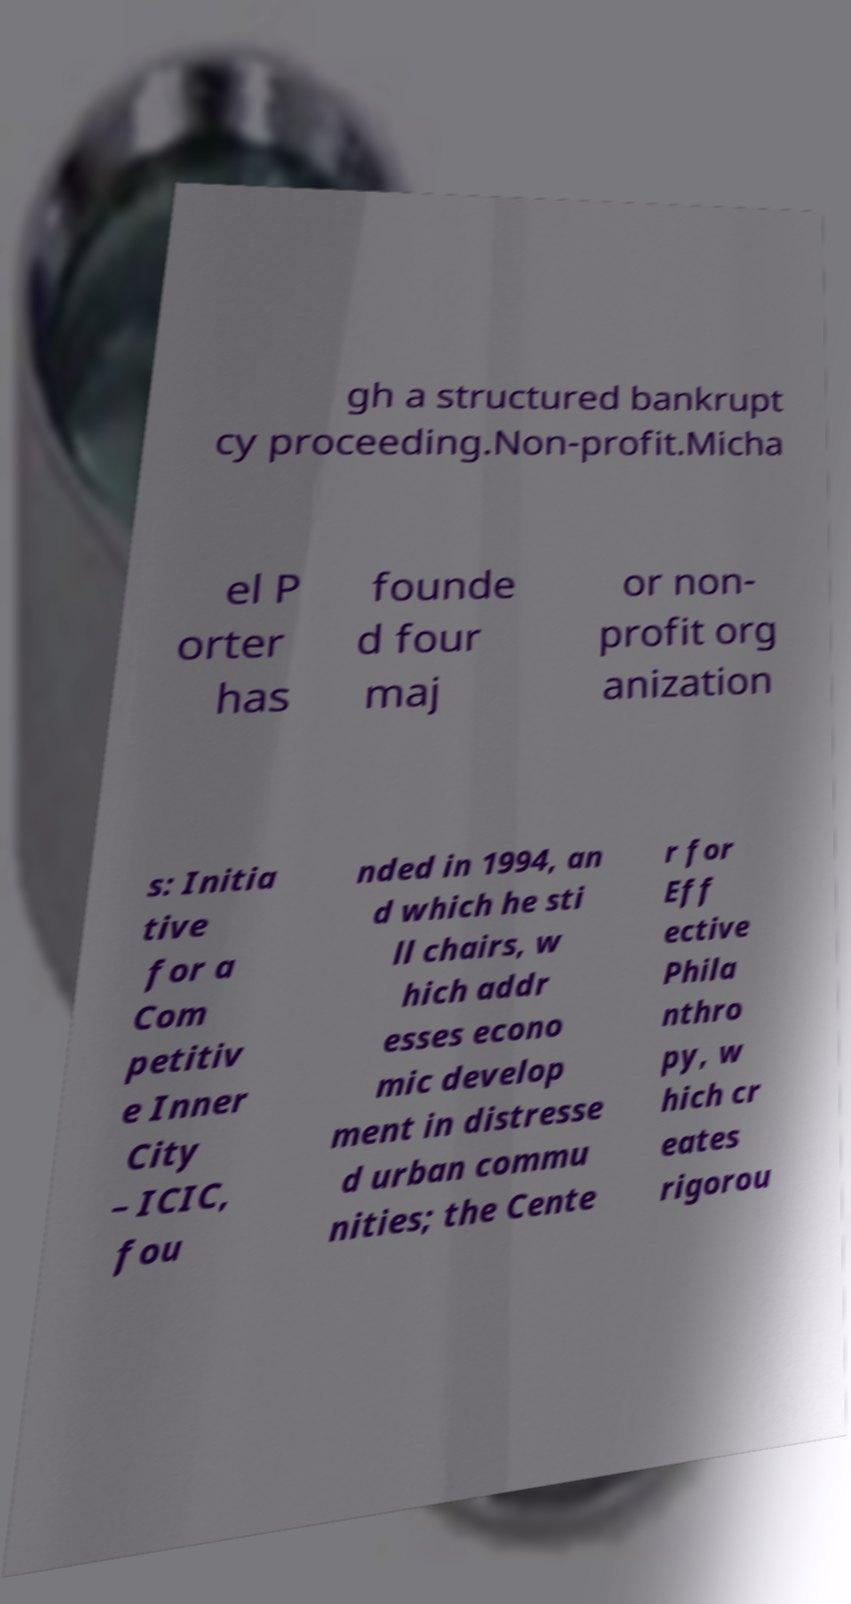Could you extract and type out the text from this image? gh a structured bankrupt cy proceeding.Non-profit.Micha el P orter has founde d four maj or non- profit org anization s: Initia tive for a Com petitiv e Inner City – ICIC, fou nded in 1994, an d which he sti ll chairs, w hich addr esses econo mic develop ment in distresse d urban commu nities; the Cente r for Eff ective Phila nthro py, w hich cr eates rigorou 